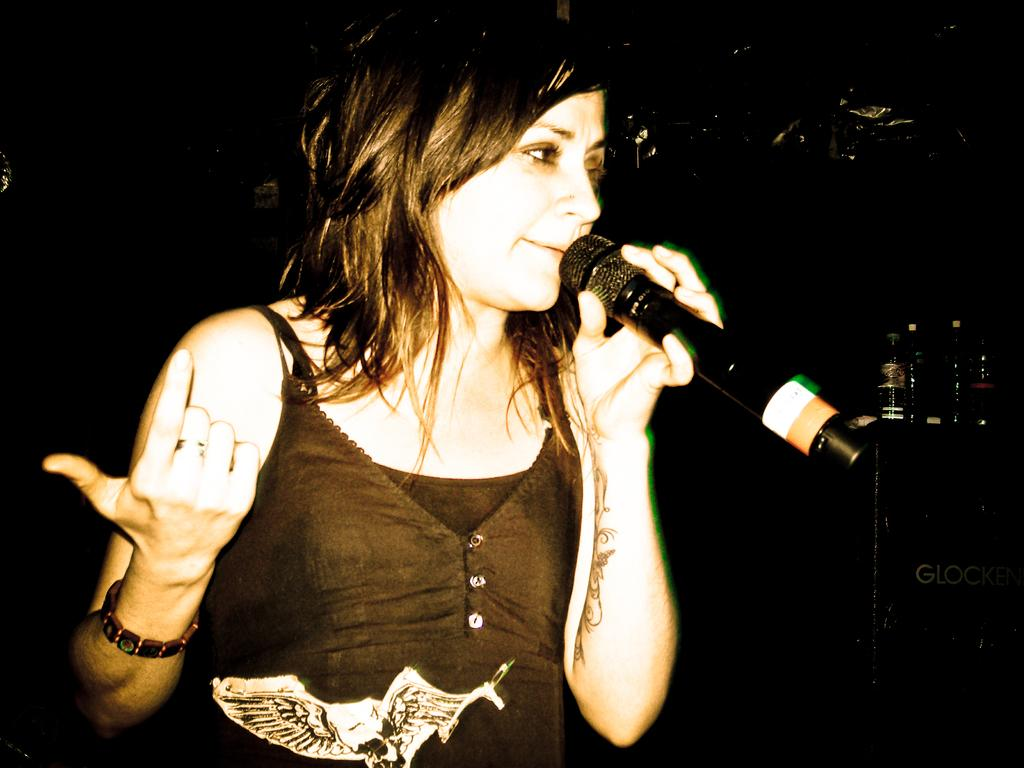What is the main subject of the image? The main subject of the image is a woman. What is the woman holding in the image? The woman is holding a mic. What type of trains can be seen in the background of the image? There are no trains visible in the image; it only features a woman holding a mic. 